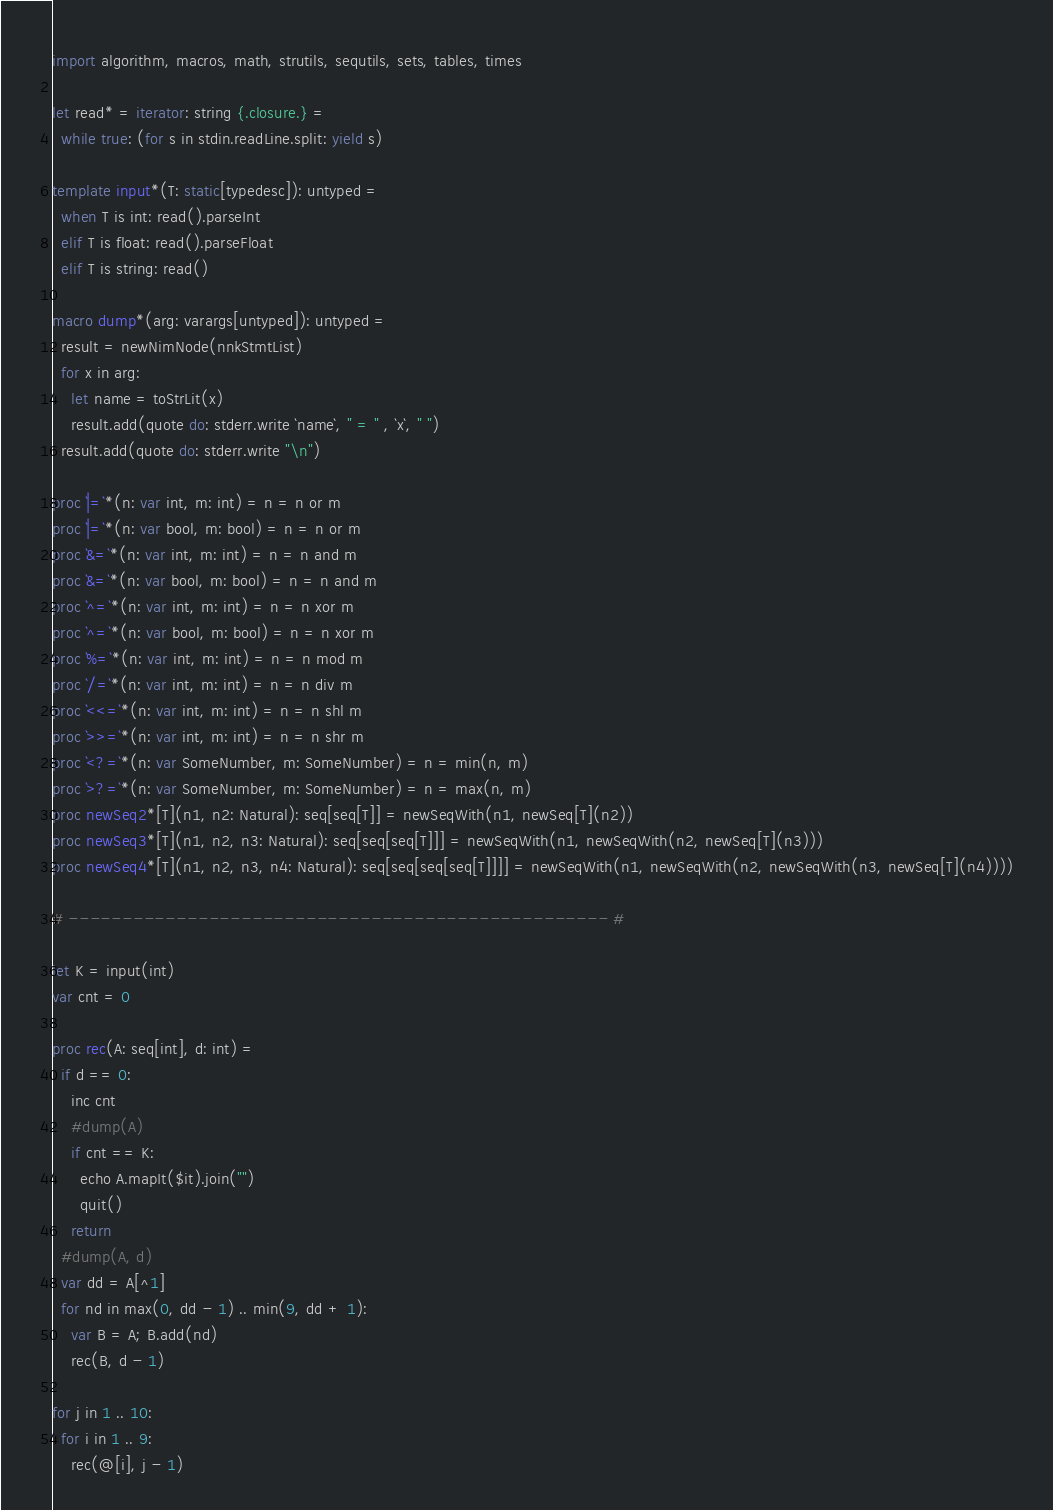<code> <loc_0><loc_0><loc_500><loc_500><_Nim_>import algorithm, macros, math, strutils, sequtils, sets, tables, times

let read* = iterator: string {.closure.} =
  while true: (for s in stdin.readLine.split: yield s)

template input*(T: static[typedesc]): untyped = 
  when T is int: read().parseInt
  elif T is float: read().parseFloat
  elif T is string: read()

macro dump*(arg: varargs[untyped]): untyped =
  result = newNimNode(nnkStmtList)
  for x in arg:
    let name = toStrLit(x)
    result.add(quote do: stderr.write `name`, " = " , `x`, " ")
  result.add(quote do: stderr.write "\n")

proc `|=`*(n: var int, m: int) = n = n or m
proc `|=`*(n: var bool, m: bool) = n = n or m
proc `&=`*(n: var int, m: int) = n = n and m
proc `&=`*(n: var bool, m: bool) = n = n and m
proc `^=`*(n: var int, m: int) = n = n xor m
proc `^=`*(n: var bool, m: bool) = n = n xor m
proc `%=`*(n: var int, m: int) = n = n mod m
proc `/=`*(n: var int, m: int) = n = n div m
proc `<<=`*(n: var int, m: int) = n = n shl m
proc `>>=`*(n: var int, m: int) = n = n shr m
proc `<?=`*(n: var SomeNumber, m: SomeNumber) = n = min(n, m)
proc `>?=`*(n: var SomeNumber, m: SomeNumber) = n = max(n, m)
proc newSeq2*[T](n1, n2: Natural): seq[seq[T]] = newSeqWith(n1, newSeq[T](n2))
proc newSeq3*[T](n1, n2, n3: Natural): seq[seq[seq[T]]] = newSeqWith(n1, newSeqWith(n2, newSeq[T](n3)))
proc newSeq4*[T](n1, n2, n3, n4: Natural): seq[seq[seq[seq[T]]]] = newSeqWith(n1, newSeqWith(n2, newSeqWith(n3, newSeq[T](n4))))

# -------------------------------------------------- #

let K = input(int)
var cnt = 0

proc rec(A: seq[int], d: int) =
  if d == 0:
    inc cnt
    #dump(A)
    if cnt == K:
      echo A.mapIt($it).join("")
      quit()
    return
  #dump(A, d)
  var dd = A[^1]
  for nd in max(0, dd - 1) .. min(9, dd + 1):
    var B = A; B.add(nd)
    rec(B, d - 1)

for j in 1 .. 10:
  for i in 1 .. 9:
    rec(@[i], j - 1)</code> 